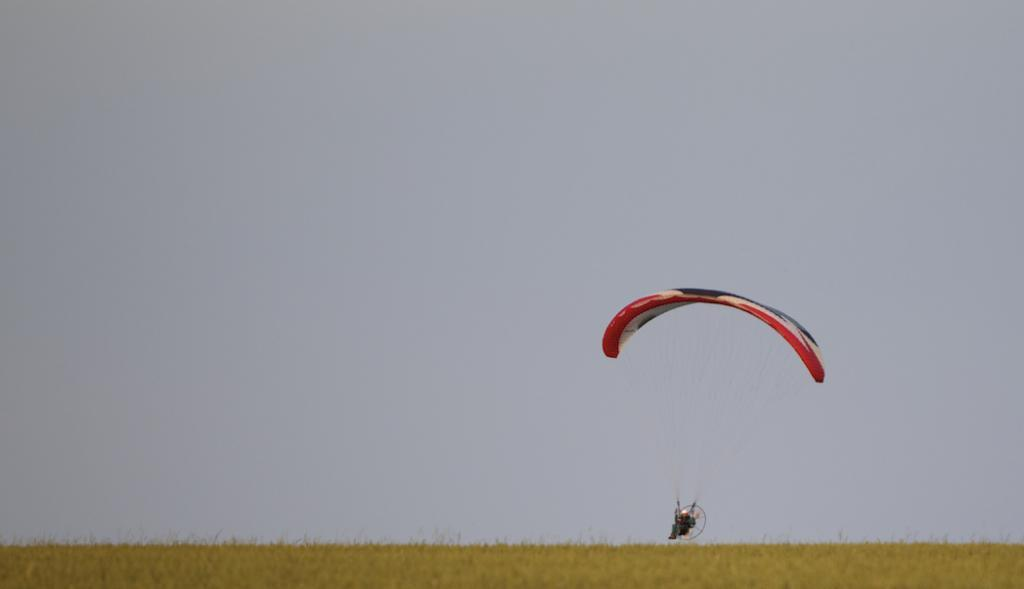What is the weather like in the image? The sky in the image is cloudy. What activity is the person in the image engaged in? There is a person paragliding in the image. What type of terrain is visible in the image? Grass is visible on the ground in the image. What type of cherry is being used to control the paraglider in the image? There is no cherry present in the image, and cherries are not used to control paragliders. 